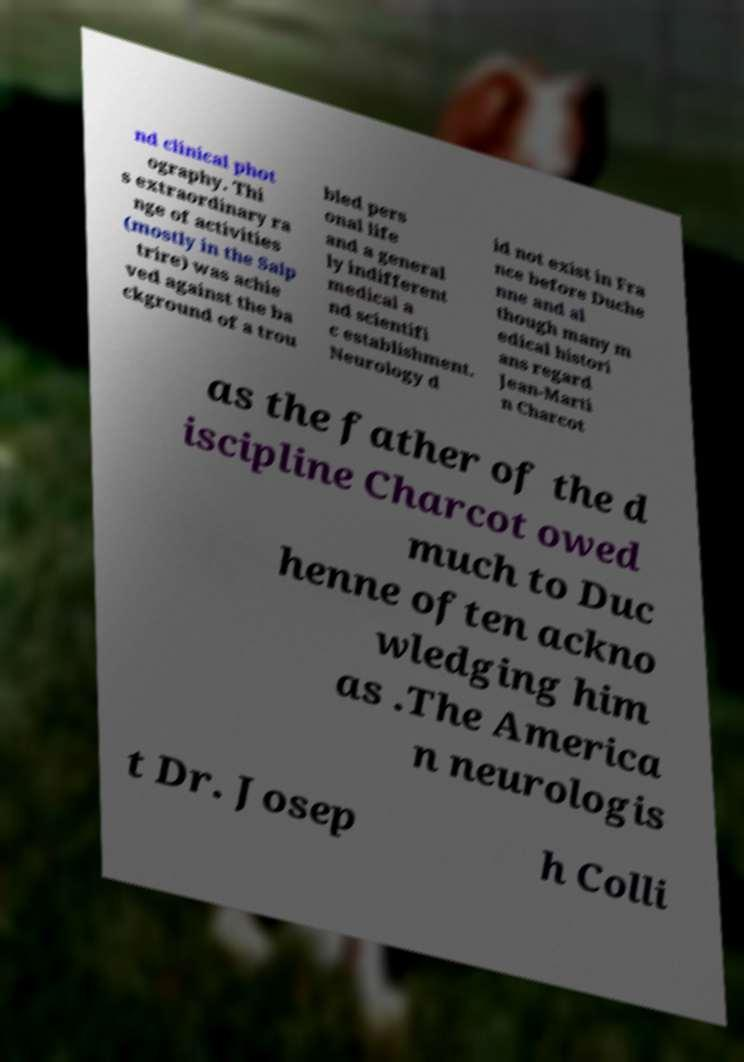Please read and relay the text visible in this image. What does it say? nd clinical phot ography. Thi s extraordinary ra nge of activities (mostly in the Salp trire) was achie ved against the ba ckground of a trou bled pers onal life and a general ly indifferent medical a nd scientifi c establishment. Neurology d id not exist in Fra nce before Duche nne and al though many m edical histori ans regard Jean-Marti n Charcot as the father of the d iscipline Charcot owed much to Duc henne often ackno wledging him as .The America n neurologis t Dr. Josep h Colli 